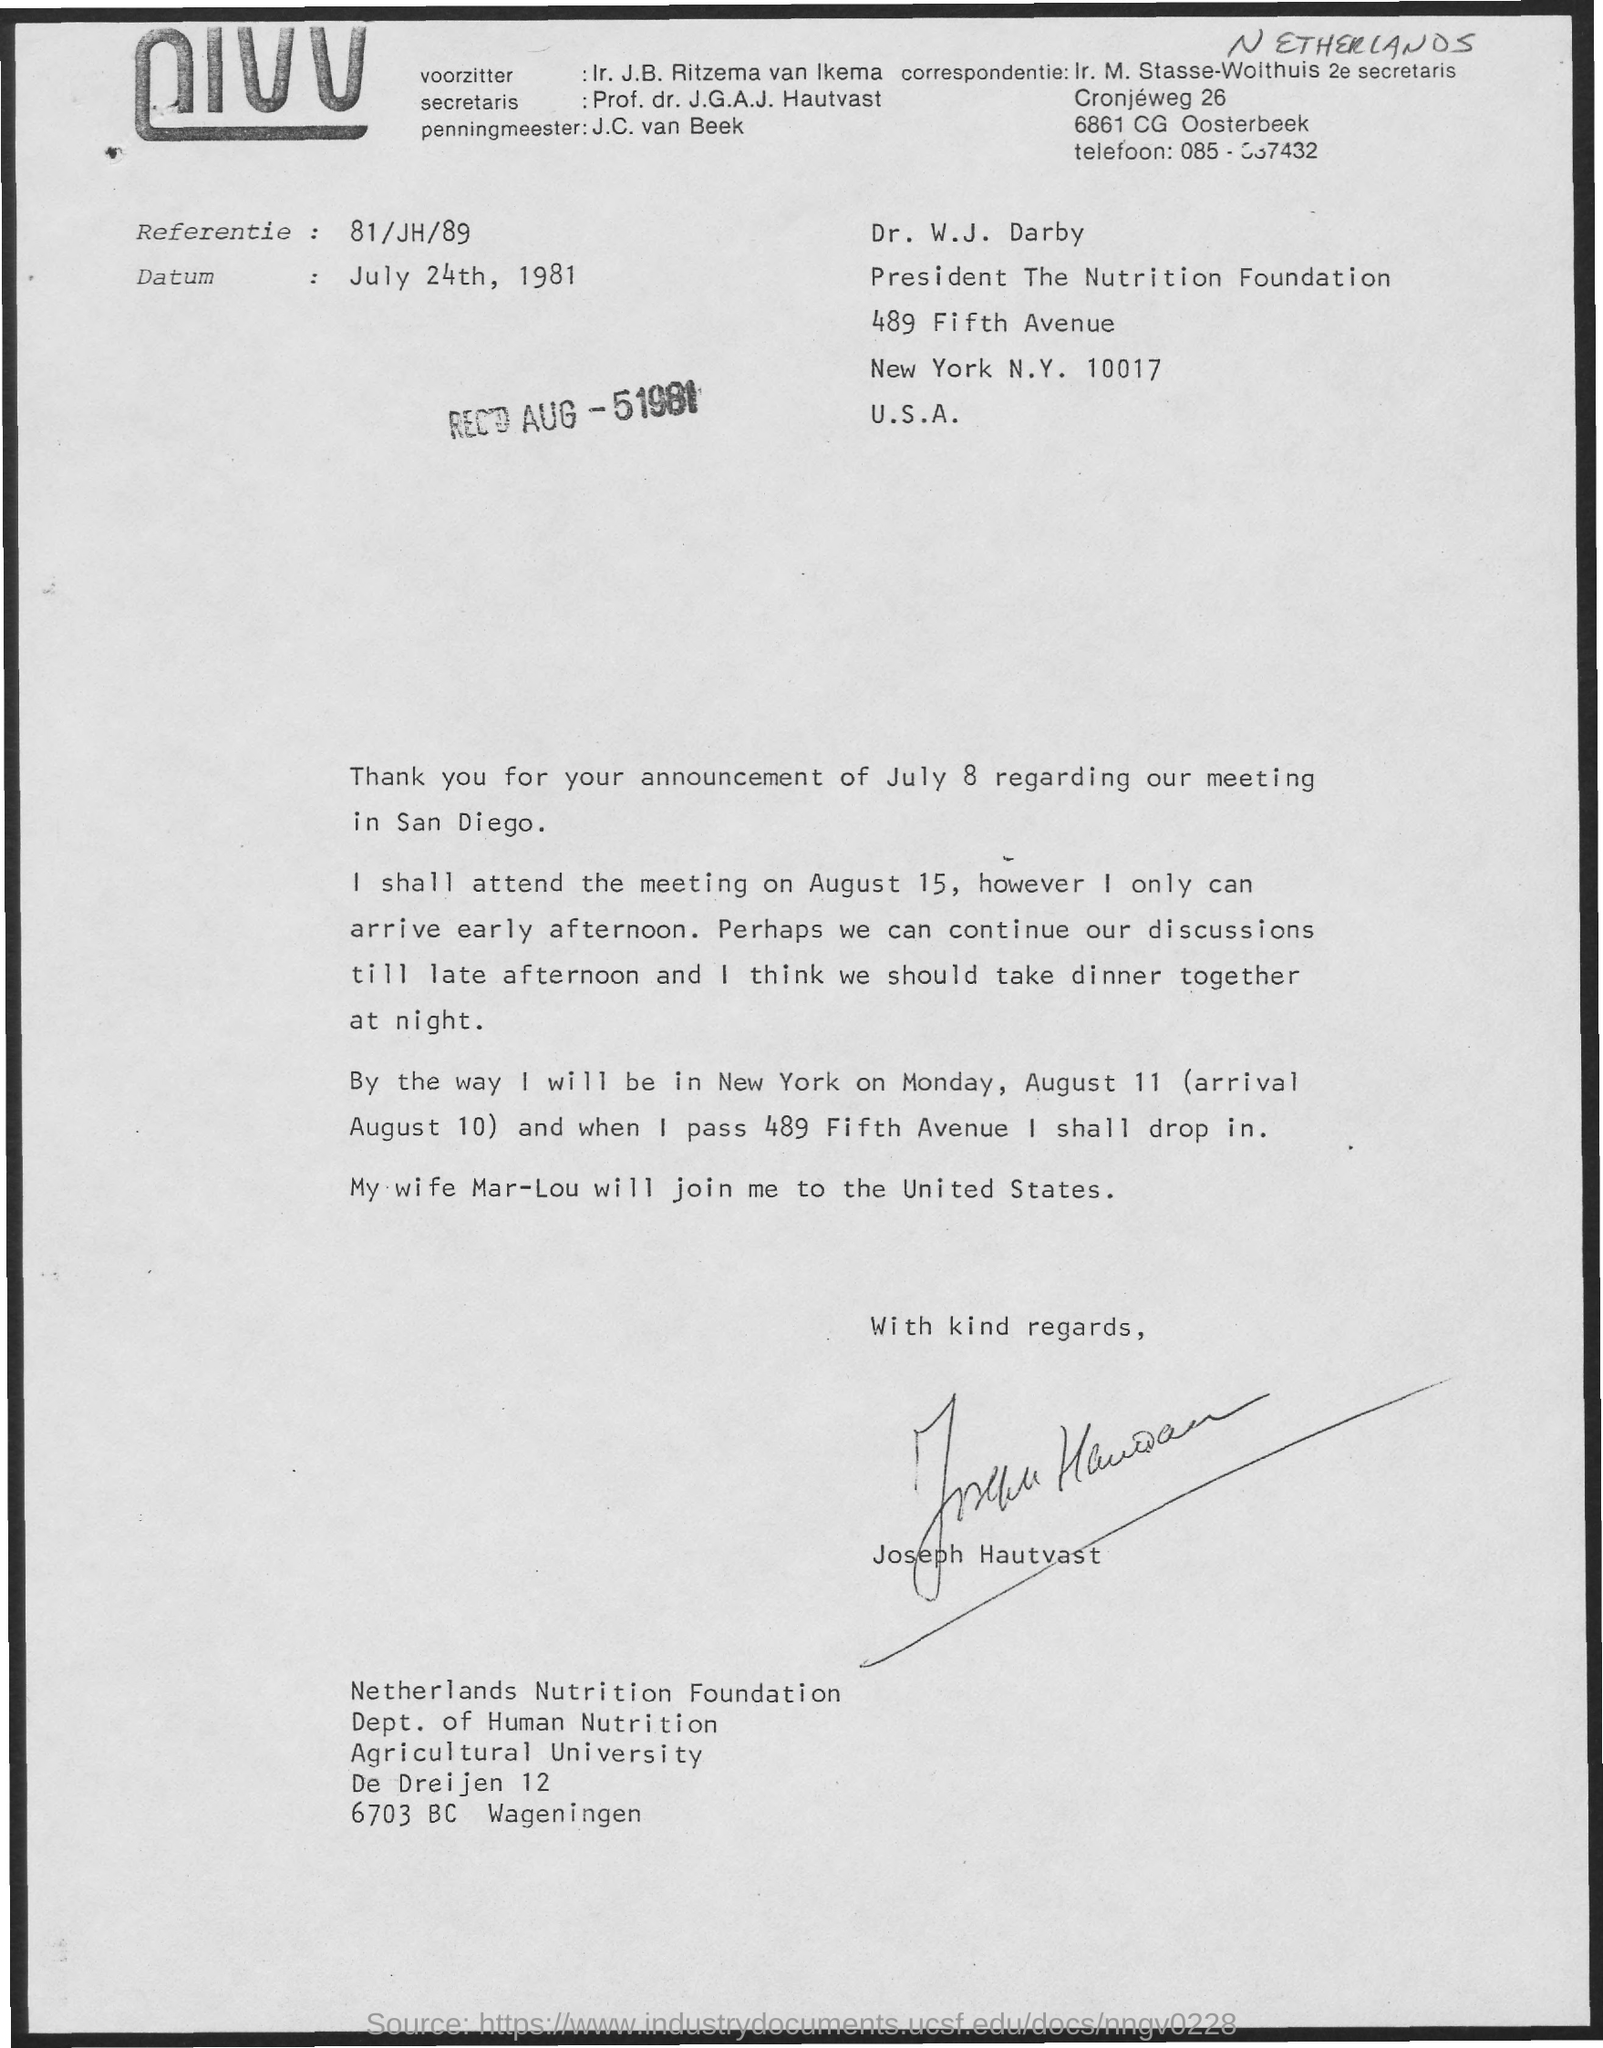Highlight a few significant elements in this photo. Joseph is married to a woman named Mar-Lou. The document is dated July 24th, 1981. Joseph Hautvast is a member of the Netherlands Nutrition Foundation. It is possible for Joseph to attend the meeting on August 15. 